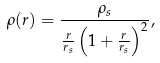Convert formula to latex. <formula><loc_0><loc_0><loc_500><loc_500>\rho ( r ) = \frac { \rho _ { s } } { \frac { r } { r _ { s } } \left ( 1 + \frac { r } { r _ { s } } \right ) ^ { 2 } } ,</formula> 